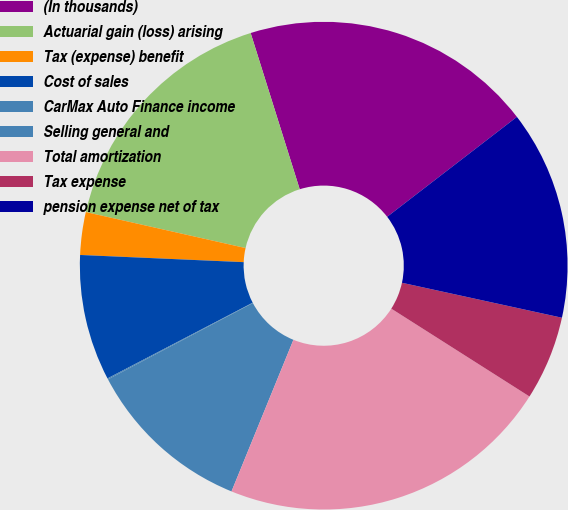Convert chart. <chart><loc_0><loc_0><loc_500><loc_500><pie_chart><fcel>(In thousands)<fcel>Actuarial gain (loss) arising<fcel>Tax (expense) benefit<fcel>Cost of sales<fcel>CarMax Auto Finance income<fcel>Selling general and<fcel>Total amortization<fcel>Tax expense<fcel>pension expense net of tax<nl><fcel>19.4%<fcel>16.63%<fcel>2.83%<fcel>8.35%<fcel>0.07%<fcel>11.11%<fcel>22.16%<fcel>5.59%<fcel>13.87%<nl></chart> 